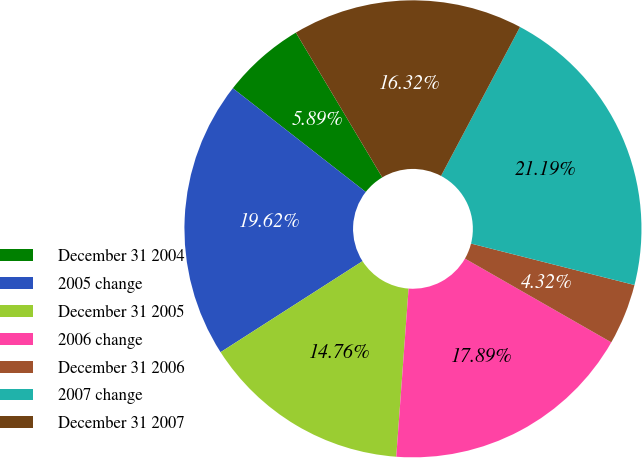Convert chart to OTSL. <chart><loc_0><loc_0><loc_500><loc_500><pie_chart><fcel>December 31 2004<fcel>2005 change<fcel>December 31 2005<fcel>2006 change<fcel>December 31 2006<fcel>2007 change<fcel>December 31 2007<nl><fcel>5.89%<fcel>19.62%<fcel>14.76%<fcel>17.89%<fcel>4.32%<fcel>21.19%<fcel>16.32%<nl></chart> 